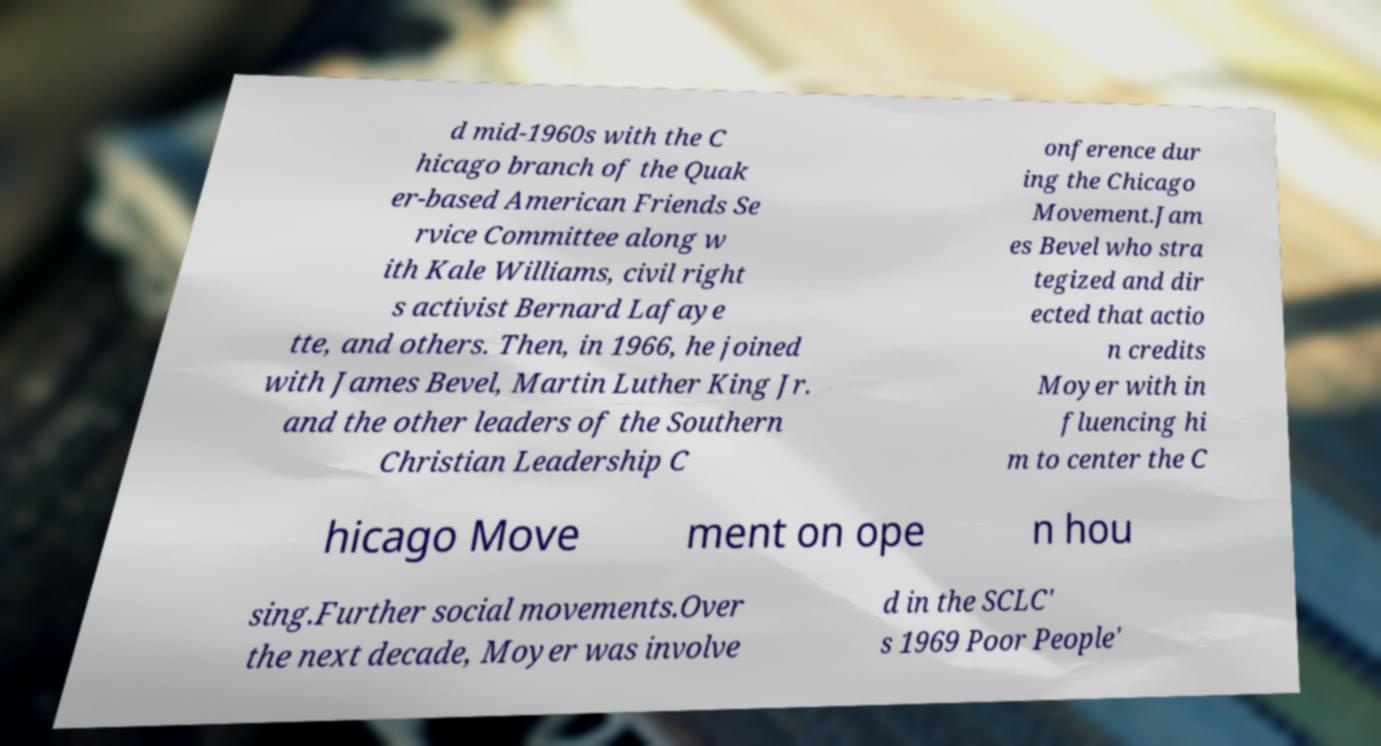Please read and relay the text visible in this image. What does it say? d mid-1960s with the C hicago branch of the Quak er-based American Friends Se rvice Committee along w ith Kale Williams, civil right s activist Bernard Lafaye tte, and others. Then, in 1966, he joined with James Bevel, Martin Luther King Jr. and the other leaders of the Southern Christian Leadership C onference dur ing the Chicago Movement.Jam es Bevel who stra tegized and dir ected that actio n credits Moyer with in fluencing hi m to center the C hicago Move ment on ope n hou sing.Further social movements.Over the next decade, Moyer was involve d in the SCLC' s 1969 Poor People' 